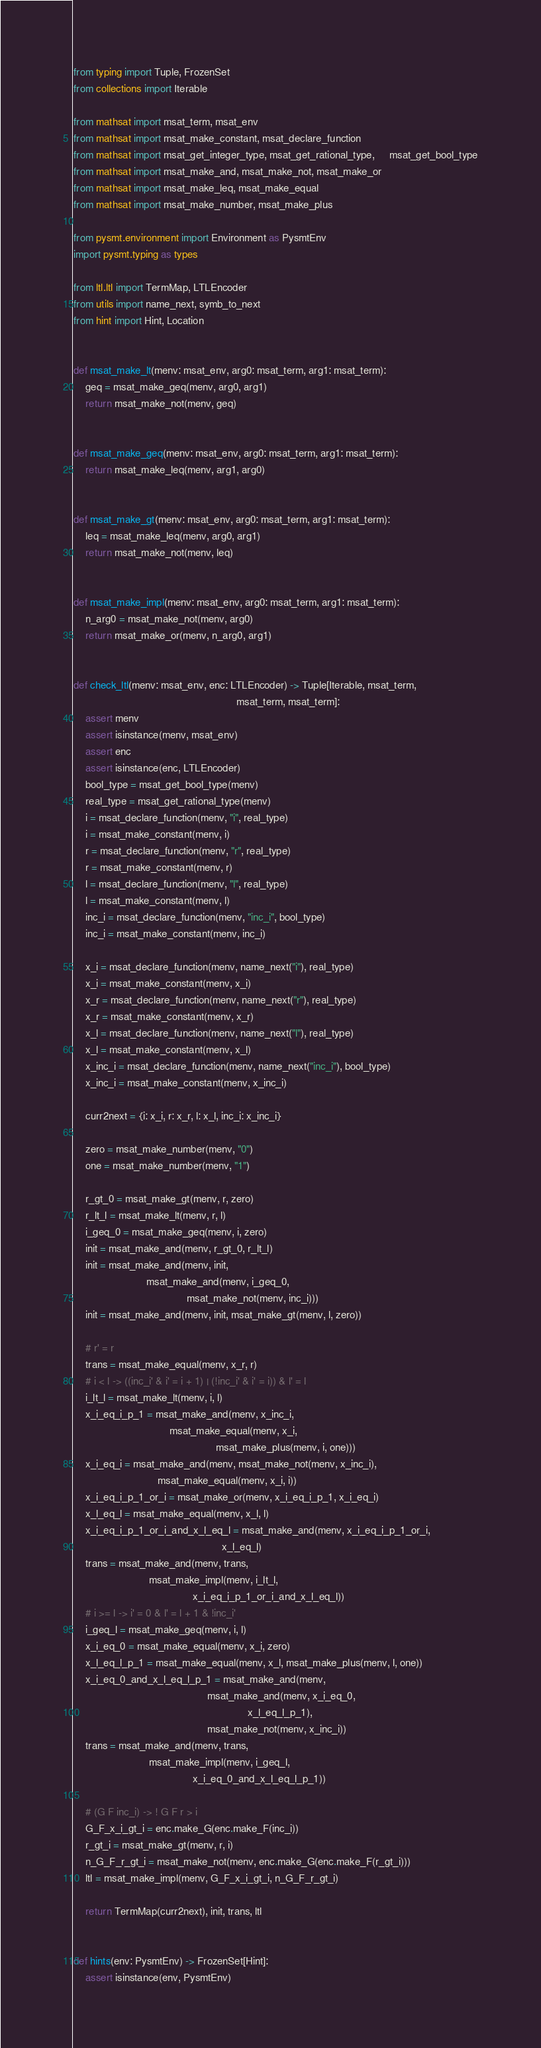<code> <loc_0><loc_0><loc_500><loc_500><_Python_>from typing import Tuple, FrozenSet
from collections import Iterable

from mathsat import msat_term, msat_env
from mathsat import msat_make_constant, msat_declare_function
from mathsat import msat_get_integer_type, msat_get_rational_type,     msat_get_bool_type
from mathsat import msat_make_and, msat_make_not, msat_make_or
from mathsat import msat_make_leq, msat_make_equal
from mathsat import msat_make_number, msat_make_plus

from pysmt.environment import Environment as PysmtEnv
import pysmt.typing as types

from ltl.ltl import TermMap, LTLEncoder
from utils import name_next, symb_to_next
from hint import Hint, Location


def msat_make_lt(menv: msat_env, arg0: msat_term, arg1: msat_term):
    geq = msat_make_geq(menv, arg0, arg1)
    return msat_make_not(menv, geq)


def msat_make_geq(menv: msat_env, arg0: msat_term, arg1: msat_term):
    return msat_make_leq(menv, arg1, arg0)


def msat_make_gt(menv: msat_env, arg0: msat_term, arg1: msat_term):
    leq = msat_make_leq(menv, arg0, arg1)
    return msat_make_not(menv, leq)


def msat_make_impl(menv: msat_env, arg0: msat_term, arg1: msat_term):
    n_arg0 = msat_make_not(menv, arg0)
    return msat_make_or(menv, n_arg0, arg1)


def check_ltl(menv: msat_env, enc: LTLEncoder) -> Tuple[Iterable, msat_term,
                                                        msat_term, msat_term]:
    assert menv
    assert isinstance(menv, msat_env)
    assert enc
    assert isinstance(enc, LTLEncoder)
    bool_type = msat_get_bool_type(menv)
    real_type = msat_get_rational_type(menv)
    i = msat_declare_function(menv, "i", real_type)
    i = msat_make_constant(menv, i)
    r = msat_declare_function(menv, "r", real_type)
    r = msat_make_constant(menv, r)
    l = msat_declare_function(menv, "l", real_type)
    l = msat_make_constant(menv, l)
    inc_i = msat_declare_function(menv, "inc_i", bool_type)
    inc_i = msat_make_constant(menv, inc_i)

    x_i = msat_declare_function(menv, name_next("i"), real_type)
    x_i = msat_make_constant(menv, x_i)
    x_r = msat_declare_function(menv, name_next("r"), real_type)
    x_r = msat_make_constant(menv, x_r)
    x_l = msat_declare_function(menv, name_next("l"), real_type)
    x_l = msat_make_constant(menv, x_l)
    x_inc_i = msat_declare_function(menv, name_next("inc_i"), bool_type)
    x_inc_i = msat_make_constant(menv, x_inc_i)

    curr2next = {i: x_i, r: x_r, l: x_l, inc_i: x_inc_i}

    zero = msat_make_number(menv, "0")
    one = msat_make_number(menv, "1")

    r_gt_0 = msat_make_gt(menv, r, zero)
    r_lt_l = msat_make_lt(menv, r, l)
    i_geq_0 = msat_make_geq(menv, i, zero)
    init = msat_make_and(menv, r_gt_0, r_lt_l)
    init = msat_make_and(menv, init,
                         msat_make_and(menv, i_geq_0,
                                       msat_make_not(menv, inc_i)))
    init = msat_make_and(menv, init, msat_make_gt(menv, l, zero))

    # r' = r
    trans = msat_make_equal(menv, x_r, r)
    # i < l -> ((inc_i' & i' = i + 1) | (!inc_i' & i' = i)) & l' = l
    i_lt_l = msat_make_lt(menv, i, l)
    x_i_eq_i_p_1 = msat_make_and(menv, x_inc_i,
                                 msat_make_equal(menv, x_i,
                                                 msat_make_plus(menv, i, one)))
    x_i_eq_i = msat_make_and(menv, msat_make_not(menv, x_inc_i),
                             msat_make_equal(menv, x_i, i))
    x_i_eq_i_p_1_or_i = msat_make_or(menv, x_i_eq_i_p_1, x_i_eq_i)
    x_l_eq_l = msat_make_equal(menv, x_l, l)
    x_i_eq_i_p_1_or_i_and_x_l_eq_l = msat_make_and(menv, x_i_eq_i_p_1_or_i,
                                                   x_l_eq_l)
    trans = msat_make_and(menv, trans,
                          msat_make_impl(menv, i_lt_l,
                                         x_i_eq_i_p_1_or_i_and_x_l_eq_l))
    # i >= l -> i' = 0 & l' = l + 1 & !inc_i'
    i_geq_l = msat_make_geq(menv, i, l)
    x_i_eq_0 = msat_make_equal(menv, x_i, zero)
    x_l_eq_l_p_1 = msat_make_equal(menv, x_l, msat_make_plus(menv, l, one))
    x_i_eq_0_and_x_l_eq_l_p_1 = msat_make_and(menv,
                                              msat_make_and(menv, x_i_eq_0,
                                                            x_l_eq_l_p_1),
                                              msat_make_not(menv, x_inc_i))
    trans = msat_make_and(menv, trans,
                          msat_make_impl(menv, i_geq_l,
                                         x_i_eq_0_and_x_l_eq_l_p_1))

    # (G F inc_i) -> ! G F r > i
    G_F_x_i_gt_i = enc.make_G(enc.make_F(inc_i))
    r_gt_i = msat_make_gt(menv, r, i)
    n_G_F_r_gt_i = msat_make_not(menv, enc.make_G(enc.make_F(r_gt_i)))
    ltl = msat_make_impl(menv, G_F_x_i_gt_i, n_G_F_r_gt_i)

    return TermMap(curr2next), init, trans, ltl


def hints(env: PysmtEnv) -> FrozenSet[Hint]:
    assert isinstance(env, PysmtEnv)
</code> 